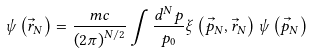<formula> <loc_0><loc_0><loc_500><loc_500>\psi \left ( { \vec { r } _ { N } } \right ) = \frac { m c } { { \left ( { 2 \pi } \right ) ^ { N / 2 } } } \int { \frac { d ^ { N } p } { p _ { 0 } } \xi \left ( { \vec { p } _ { N } , \vec { r } _ { N } } \right ) \psi \left ( { \vec { p } _ { N } } \right ) }</formula> 